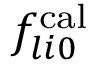<formula> <loc_0><loc_0><loc_500><loc_500>f _ { l i 0 } ^ { c a l }</formula> 